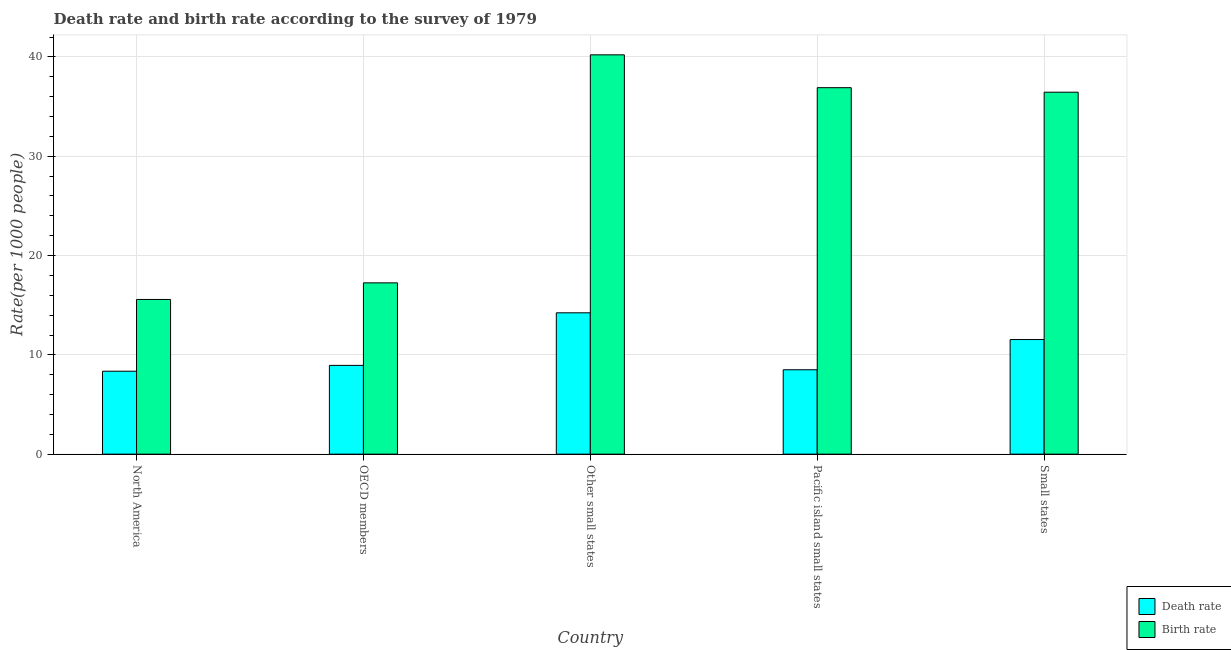Are the number of bars on each tick of the X-axis equal?
Keep it short and to the point. Yes. How many bars are there on the 3rd tick from the left?
Give a very brief answer. 2. How many bars are there on the 5th tick from the right?
Keep it short and to the point. 2. What is the birth rate in Small states?
Offer a very short reply. 36.45. Across all countries, what is the maximum death rate?
Your response must be concise. 14.24. Across all countries, what is the minimum death rate?
Provide a succinct answer. 8.35. In which country was the birth rate maximum?
Give a very brief answer. Other small states. In which country was the death rate minimum?
Ensure brevity in your answer.  North America. What is the total death rate in the graph?
Offer a very short reply. 51.57. What is the difference between the birth rate in North America and that in OECD members?
Provide a succinct answer. -1.67. What is the difference between the death rate in OECD members and the birth rate in Other small states?
Your answer should be very brief. -31.27. What is the average death rate per country?
Give a very brief answer. 10.31. What is the difference between the birth rate and death rate in OECD members?
Make the answer very short. 8.31. In how many countries, is the death rate greater than 30 ?
Keep it short and to the point. 0. What is the ratio of the birth rate in North America to that in Pacific island small states?
Your response must be concise. 0.42. Is the death rate in North America less than that in OECD members?
Make the answer very short. Yes. What is the difference between the highest and the second highest death rate?
Offer a terse response. 2.69. What is the difference between the highest and the lowest death rate?
Provide a short and direct response. 5.88. Is the sum of the birth rate in OECD members and Small states greater than the maximum death rate across all countries?
Provide a short and direct response. Yes. What does the 2nd bar from the left in Other small states represents?
Keep it short and to the point. Birth rate. What does the 2nd bar from the right in OECD members represents?
Provide a succinct answer. Death rate. How many bars are there?
Ensure brevity in your answer.  10. Are all the bars in the graph horizontal?
Your response must be concise. No. How many countries are there in the graph?
Ensure brevity in your answer.  5. What is the difference between two consecutive major ticks on the Y-axis?
Provide a short and direct response. 10. Are the values on the major ticks of Y-axis written in scientific E-notation?
Give a very brief answer. No. Does the graph contain any zero values?
Your answer should be very brief. No. Does the graph contain grids?
Make the answer very short. Yes. How many legend labels are there?
Offer a very short reply. 2. How are the legend labels stacked?
Ensure brevity in your answer.  Vertical. What is the title of the graph?
Make the answer very short. Death rate and birth rate according to the survey of 1979. What is the label or title of the Y-axis?
Your response must be concise. Rate(per 1000 people). What is the Rate(per 1000 people) in Death rate in North America?
Provide a short and direct response. 8.35. What is the Rate(per 1000 people) in Birth rate in North America?
Provide a succinct answer. 15.58. What is the Rate(per 1000 people) in Death rate in OECD members?
Offer a terse response. 8.94. What is the Rate(per 1000 people) of Birth rate in OECD members?
Offer a terse response. 17.25. What is the Rate(per 1000 people) of Death rate in Other small states?
Give a very brief answer. 14.24. What is the Rate(per 1000 people) of Birth rate in Other small states?
Provide a succinct answer. 40.22. What is the Rate(per 1000 people) of Death rate in Pacific island small states?
Give a very brief answer. 8.5. What is the Rate(per 1000 people) in Birth rate in Pacific island small states?
Make the answer very short. 36.91. What is the Rate(per 1000 people) of Death rate in Small states?
Keep it short and to the point. 11.54. What is the Rate(per 1000 people) in Birth rate in Small states?
Provide a succinct answer. 36.45. Across all countries, what is the maximum Rate(per 1000 people) in Death rate?
Keep it short and to the point. 14.24. Across all countries, what is the maximum Rate(per 1000 people) in Birth rate?
Provide a succinct answer. 40.22. Across all countries, what is the minimum Rate(per 1000 people) of Death rate?
Offer a very short reply. 8.35. Across all countries, what is the minimum Rate(per 1000 people) of Birth rate?
Offer a very short reply. 15.58. What is the total Rate(per 1000 people) of Death rate in the graph?
Offer a very short reply. 51.57. What is the total Rate(per 1000 people) of Birth rate in the graph?
Your answer should be compact. 146.41. What is the difference between the Rate(per 1000 people) of Death rate in North America and that in OECD members?
Provide a short and direct response. -0.59. What is the difference between the Rate(per 1000 people) of Birth rate in North America and that in OECD members?
Provide a succinct answer. -1.67. What is the difference between the Rate(per 1000 people) in Death rate in North America and that in Other small states?
Make the answer very short. -5.88. What is the difference between the Rate(per 1000 people) of Birth rate in North America and that in Other small states?
Ensure brevity in your answer.  -24.64. What is the difference between the Rate(per 1000 people) of Death rate in North America and that in Pacific island small states?
Give a very brief answer. -0.15. What is the difference between the Rate(per 1000 people) in Birth rate in North America and that in Pacific island small states?
Offer a terse response. -21.33. What is the difference between the Rate(per 1000 people) of Death rate in North America and that in Small states?
Ensure brevity in your answer.  -3.19. What is the difference between the Rate(per 1000 people) in Birth rate in North America and that in Small states?
Offer a terse response. -20.87. What is the difference between the Rate(per 1000 people) of Death rate in OECD members and that in Other small states?
Keep it short and to the point. -5.29. What is the difference between the Rate(per 1000 people) in Birth rate in OECD members and that in Other small states?
Give a very brief answer. -22.96. What is the difference between the Rate(per 1000 people) of Death rate in OECD members and that in Pacific island small states?
Ensure brevity in your answer.  0.44. What is the difference between the Rate(per 1000 people) in Birth rate in OECD members and that in Pacific island small states?
Keep it short and to the point. -19.66. What is the difference between the Rate(per 1000 people) of Death rate in OECD members and that in Small states?
Provide a short and direct response. -2.6. What is the difference between the Rate(per 1000 people) of Birth rate in OECD members and that in Small states?
Ensure brevity in your answer.  -19.2. What is the difference between the Rate(per 1000 people) of Death rate in Other small states and that in Pacific island small states?
Your answer should be very brief. 5.73. What is the difference between the Rate(per 1000 people) of Birth rate in Other small states and that in Pacific island small states?
Make the answer very short. 3.31. What is the difference between the Rate(per 1000 people) in Death rate in Other small states and that in Small states?
Your response must be concise. 2.69. What is the difference between the Rate(per 1000 people) of Birth rate in Other small states and that in Small states?
Your answer should be compact. 3.76. What is the difference between the Rate(per 1000 people) in Death rate in Pacific island small states and that in Small states?
Offer a very short reply. -3.04. What is the difference between the Rate(per 1000 people) in Birth rate in Pacific island small states and that in Small states?
Your answer should be very brief. 0.45. What is the difference between the Rate(per 1000 people) in Death rate in North America and the Rate(per 1000 people) in Birth rate in OECD members?
Provide a short and direct response. -8.9. What is the difference between the Rate(per 1000 people) in Death rate in North America and the Rate(per 1000 people) in Birth rate in Other small states?
Provide a short and direct response. -31.86. What is the difference between the Rate(per 1000 people) of Death rate in North America and the Rate(per 1000 people) of Birth rate in Pacific island small states?
Offer a very short reply. -28.55. What is the difference between the Rate(per 1000 people) in Death rate in North America and the Rate(per 1000 people) in Birth rate in Small states?
Provide a succinct answer. -28.1. What is the difference between the Rate(per 1000 people) of Death rate in OECD members and the Rate(per 1000 people) of Birth rate in Other small states?
Your answer should be very brief. -31.27. What is the difference between the Rate(per 1000 people) in Death rate in OECD members and the Rate(per 1000 people) in Birth rate in Pacific island small states?
Your answer should be compact. -27.97. What is the difference between the Rate(per 1000 people) in Death rate in OECD members and the Rate(per 1000 people) in Birth rate in Small states?
Ensure brevity in your answer.  -27.51. What is the difference between the Rate(per 1000 people) in Death rate in Other small states and the Rate(per 1000 people) in Birth rate in Pacific island small states?
Provide a short and direct response. -22.67. What is the difference between the Rate(per 1000 people) in Death rate in Other small states and the Rate(per 1000 people) in Birth rate in Small states?
Your answer should be very brief. -22.22. What is the difference between the Rate(per 1000 people) of Death rate in Pacific island small states and the Rate(per 1000 people) of Birth rate in Small states?
Give a very brief answer. -27.95. What is the average Rate(per 1000 people) of Death rate per country?
Keep it short and to the point. 10.31. What is the average Rate(per 1000 people) of Birth rate per country?
Your answer should be compact. 29.28. What is the difference between the Rate(per 1000 people) in Death rate and Rate(per 1000 people) in Birth rate in North America?
Your answer should be very brief. -7.23. What is the difference between the Rate(per 1000 people) of Death rate and Rate(per 1000 people) of Birth rate in OECD members?
Your response must be concise. -8.31. What is the difference between the Rate(per 1000 people) in Death rate and Rate(per 1000 people) in Birth rate in Other small states?
Keep it short and to the point. -25.98. What is the difference between the Rate(per 1000 people) of Death rate and Rate(per 1000 people) of Birth rate in Pacific island small states?
Provide a short and direct response. -28.41. What is the difference between the Rate(per 1000 people) in Death rate and Rate(per 1000 people) in Birth rate in Small states?
Make the answer very short. -24.91. What is the ratio of the Rate(per 1000 people) of Death rate in North America to that in OECD members?
Offer a terse response. 0.93. What is the ratio of the Rate(per 1000 people) in Birth rate in North America to that in OECD members?
Ensure brevity in your answer.  0.9. What is the ratio of the Rate(per 1000 people) of Death rate in North America to that in Other small states?
Your response must be concise. 0.59. What is the ratio of the Rate(per 1000 people) in Birth rate in North America to that in Other small states?
Give a very brief answer. 0.39. What is the ratio of the Rate(per 1000 people) in Death rate in North America to that in Pacific island small states?
Give a very brief answer. 0.98. What is the ratio of the Rate(per 1000 people) in Birth rate in North America to that in Pacific island small states?
Offer a terse response. 0.42. What is the ratio of the Rate(per 1000 people) of Death rate in North America to that in Small states?
Keep it short and to the point. 0.72. What is the ratio of the Rate(per 1000 people) in Birth rate in North America to that in Small states?
Your answer should be compact. 0.43. What is the ratio of the Rate(per 1000 people) in Death rate in OECD members to that in Other small states?
Offer a terse response. 0.63. What is the ratio of the Rate(per 1000 people) of Birth rate in OECD members to that in Other small states?
Provide a short and direct response. 0.43. What is the ratio of the Rate(per 1000 people) in Death rate in OECD members to that in Pacific island small states?
Your answer should be very brief. 1.05. What is the ratio of the Rate(per 1000 people) in Birth rate in OECD members to that in Pacific island small states?
Offer a terse response. 0.47. What is the ratio of the Rate(per 1000 people) of Death rate in OECD members to that in Small states?
Make the answer very short. 0.77. What is the ratio of the Rate(per 1000 people) in Birth rate in OECD members to that in Small states?
Your response must be concise. 0.47. What is the ratio of the Rate(per 1000 people) in Death rate in Other small states to that in Pacific island small states?
Provide a short and direct response. 1.67. What is the ratio of the Rate(per 1000 people) in Birth rate in Other small states to that in Pacific island small states?
Your response must be concise. 1.09. What is the ratio of the Rate(per 1000 people) in Death rate in Other small states to that in Small states?
Give a very brief answer. 1.23. What is the ratio of the Rate(per 1000 people) of Birth rate in Other small states to that in Small states?
Ensure brevity in your answer.  1.1. What is the ratio of the Rate(per 1000 people) in Death rate in Pacific island small states to that in Small states?
Your answer should be very brief. 0.74. What is the ratio of the Rate(per 1000 people) in Birth rate in Pacific island small states to that in Small states?
Keep it short and to the point. 1.01. What is the difference between the highest and the second highest Rate(per 1000 people) in Death rate?
Your response must be concise. 2.69. What is the difference between the highest and the second highest Rate(per 1000 people) in Birth rate?
Provide a succinct answer. 3.31. What is the difference between the highest and the lowest Rate(per 1000 people) of Death rate?
Your answer should be very brief. 5.88. What is the difference between the highest and the lowest Rate(per 1000 people) of Birth rate?
Give a very brief answer. 24.64. 